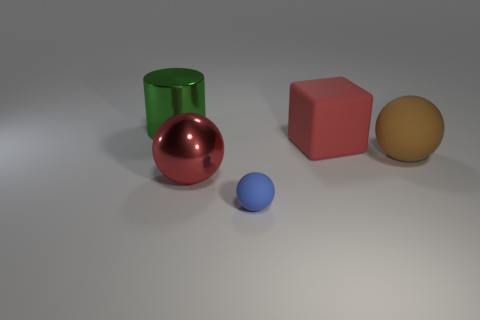Subtract all brown matte balls. How many balls are left? 2 Subtract all blue spheres. How many spheres are left? 2 Subtract all cylinders. How many objects are left? 4 Add 2 big balls. How many objects exist? 7 Add 4 blue blocks. How many blue blocks exist? 4 Subtract 0 green spheres. How many objects are left? 5 Subtract 2 spheres. How many spheres are left? 1 Subtract all blue cylinders. Subtract all gray balls. How many cylinders are left? 1 Subtract all gray cylinders. How many blue spheres are left? 1 Subtract all small brown rubber cubes. Subtract all red objects. How many objects are left? 3 